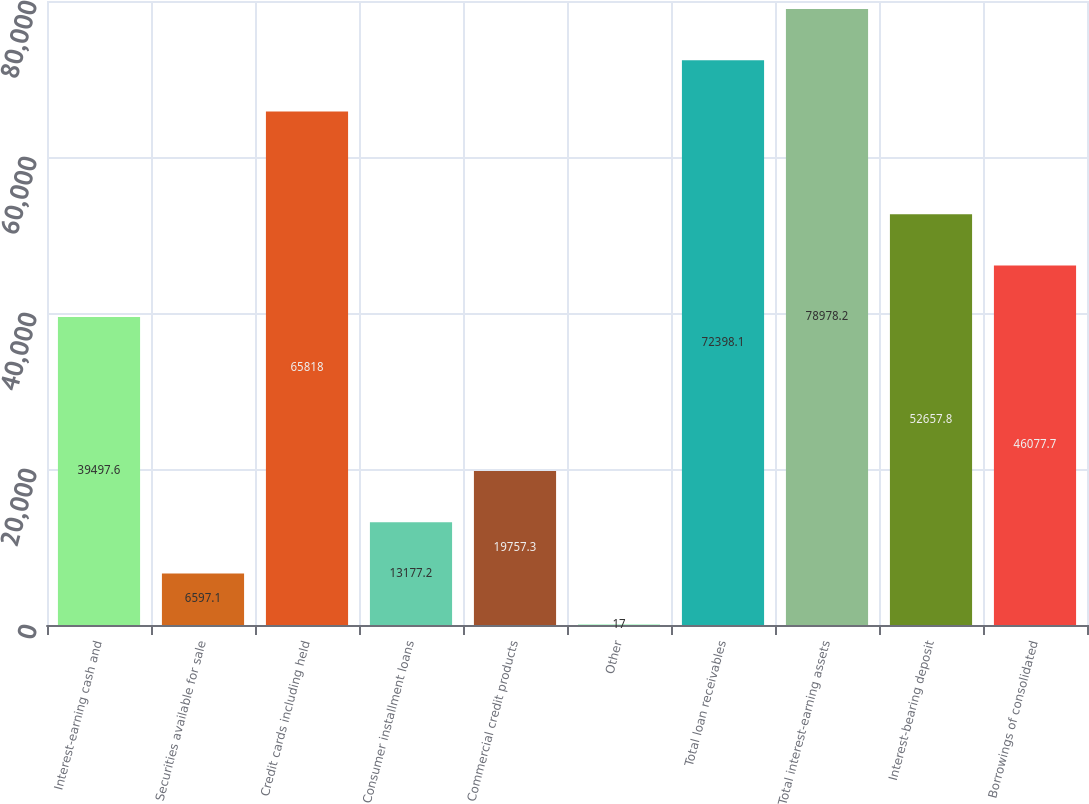<chart> <loc_0><loc_0><loc_500><loc_500><bar_chart><fcel>Interest-earning cash and<fcel>Securities available for sale<fcel>Credit cards including held<fcel>Consumer installment loans<fcel>Commercial credit products<fcel>Other<fcel>Total loan receivables<fcel>Total interest-earning assets<fcel>Interest-bearing deposit<fcel>Borrowings of consolidated<nl><fcel>39497.6<fcel>6597.1<fcel>65818<fcel>13177.2<fcel>19757.3<fcel>17<fcel>72398.1<fcel>78978.2<fcel>52657.8<fcel>46077.7<nl></chart> 